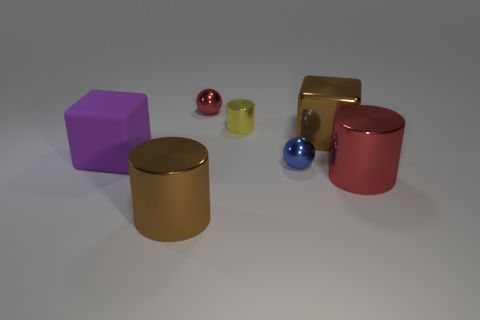Subtract all large cylinders. How many cylinders are left? 1 Add 1 brown things. How many objects exist? 8 Subtract all spheres. How many objects are left? 5 Subtract all tiny red objects. Subtract all brown metallic objects. How many objects are left? 4 Add 3 red objects. How many red objects are left? 5 Add 3 large purple matte cubes. How many large purple matte cubes exist? 4 Subtract 1 brown cylinders. How many objects are left? 6 